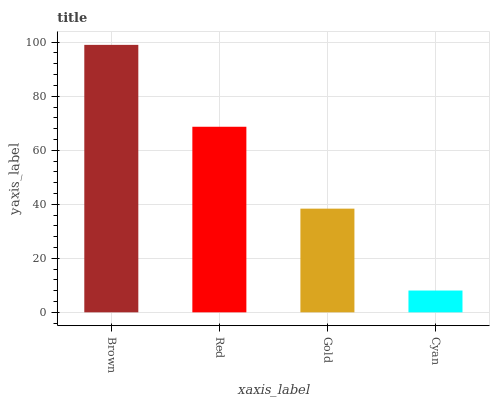Is Cyan the minimum?
Answer yes or no. Yes. Is Brown the maximum?
Answer yes or no. Yes. Is Red the minimum?
Answer yes or no. No. Is Red the maximum?
Answer yes or no. No. Is Brown greater than Red?
Answer yes or no. Yes. Is Red less than Brown?
Answer yes or no. Yes. Is Red greater than Brown?
Answer yes or no. No. Is Brown less than Red?
Answer yes or no. No. Is Red the high median?
Answer yes or no. Yes. Is Gold the low median?
Answer yes or no. Yes. Is Cyan the high median?
Answer yes or no. No. Is Red the low median?
Answer yes or no. No. 